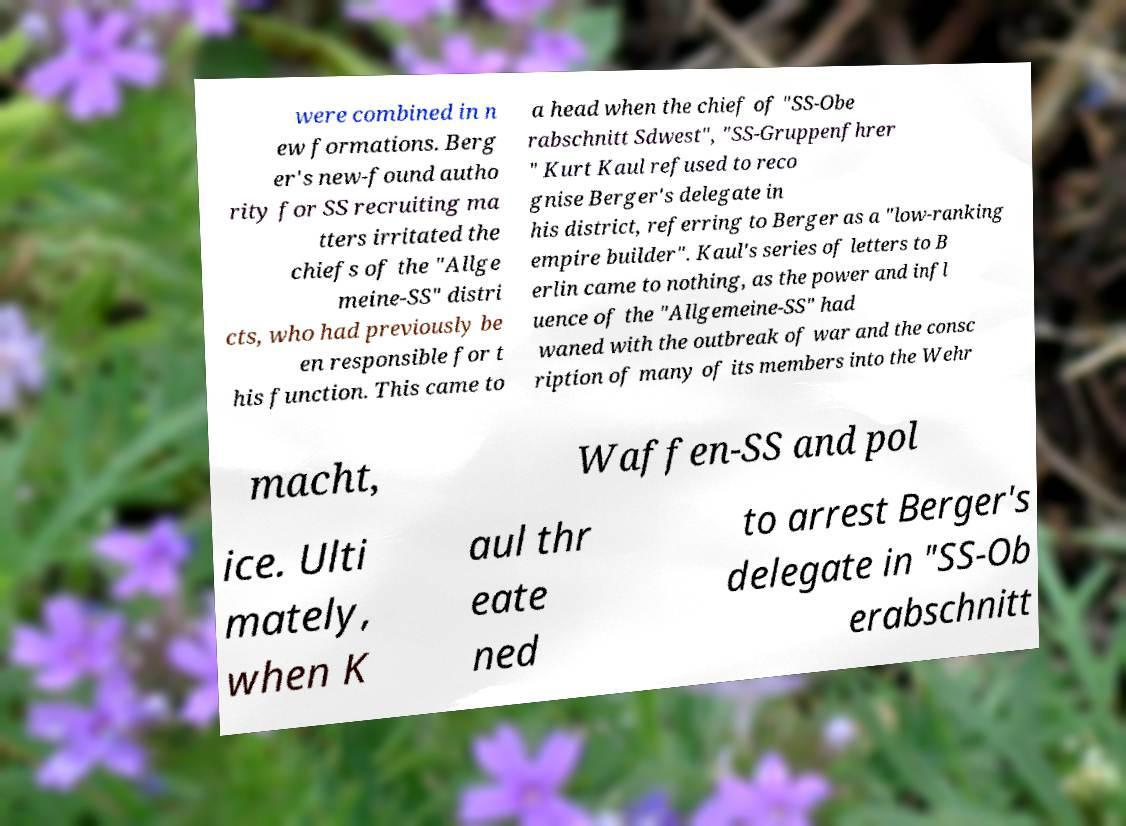For documentation purposes, I need the text within this image transcribed. Could you provide that? were combined in n ew formations. Berg er's new-found autho rity for SS recruiting ma tters irritated the chiefs of the "Allge meine-SS" distri cts, who had previously be en responsible for t his function. This came to a head when the chief of "SS-Obe rabschnitt Sdwest", "SS-Gruppenfhrer " Kurt Kaul refused to reco gnise Berger's delegate in his district, referring to Berger as a "low-ranking empire builder". Kaul's series of letters to B erlin came to nothing, as the power and infl uence of the "Allgemeine-SS" had waned with the outbreak of war and the consc ription of many of its members into the Wehr macht, Waffen-SS and pol ice. Ulti mately, when K aul thr eate ned to arrest Berger's delegate in "SS-Ob erabschnitt 